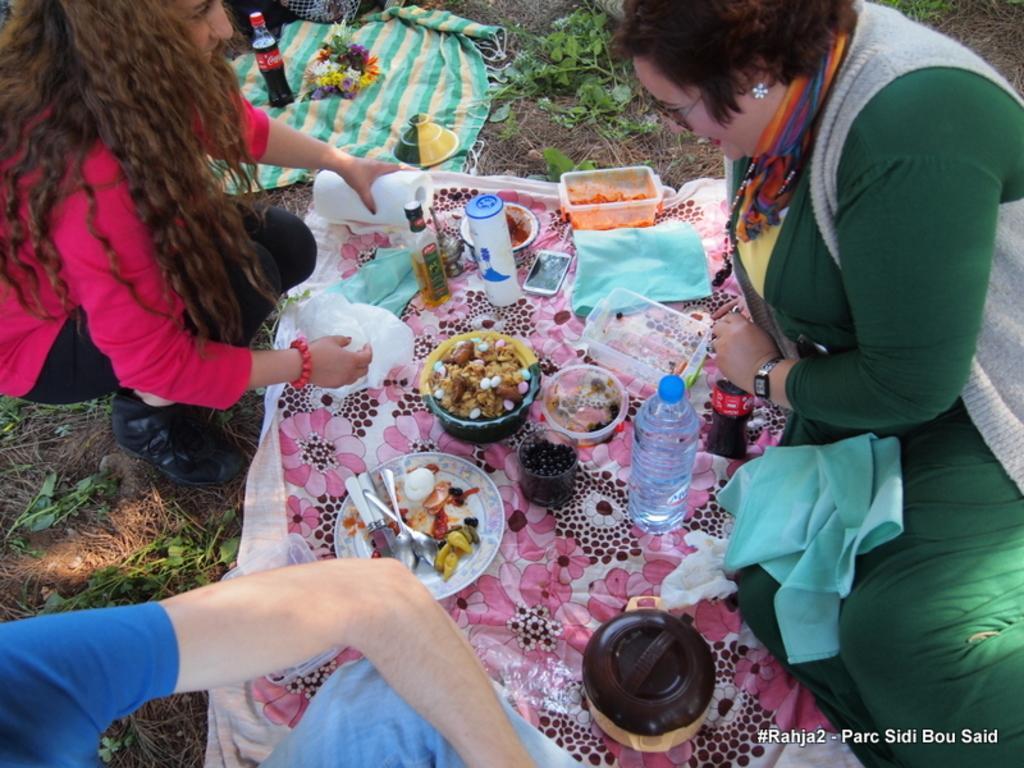Describe this image in one or two sentences. On the right side of the picture there is a woman. On the left side of the picture there is a woman and a person standing. In the center of the picture there is a cloth, on the cloth there are plates, bowls, boxes, bottles, mobile, phone and various food items. At the top there are plants, flowers and a coke bottle. 